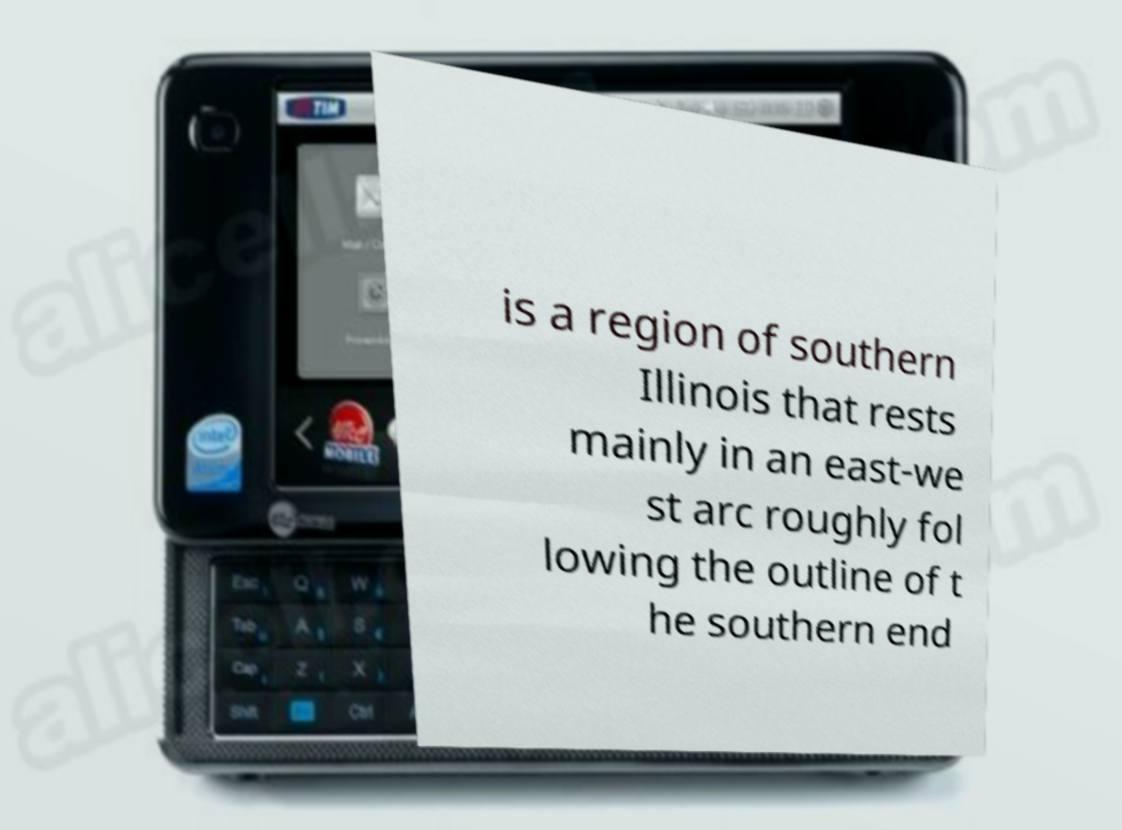Could you assist in decoding the text presented in this image and type it out clearly? is a region of southern Illinois that rests mainly in an east-we st arc roughly fol lowing the outline of t he southern end 